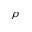<formula> <loc_0><loc_0><loc_500><loc_500>\rho</formula> 